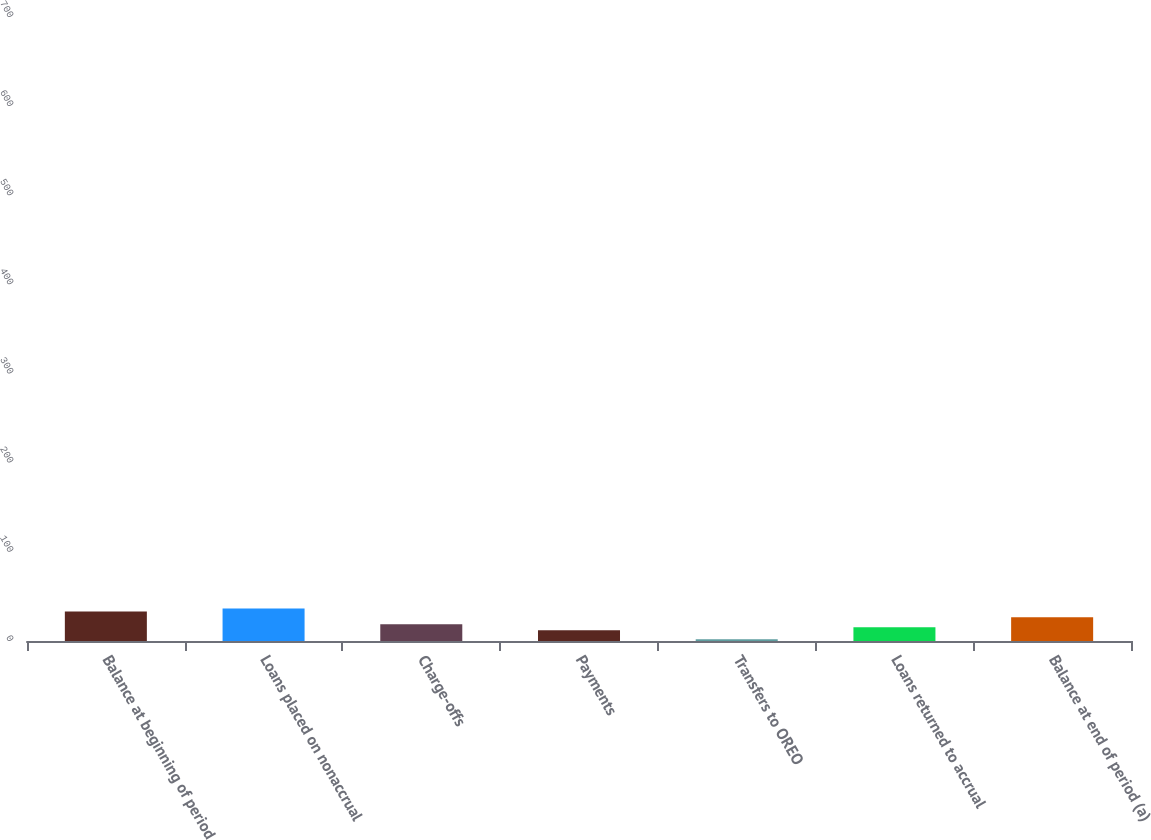Convert chart to OTSL. <chart><loc_0><loc_0><loc_500><loc_500><bar_chart><fcel>Balance at beginning of period<fcel>Loans placed on nonaccrual<fcel>Charge-offs<fcel>Payments<fcel>Transfers to OREO<fcel>Loans returned to accrual<fcel>Balance at end of period (a)<nl><fcel>625<fcel>689.2<fcel>355.4<fcel>227<fcel>37<fcel>291.2<fcel>503<nl></chart> 